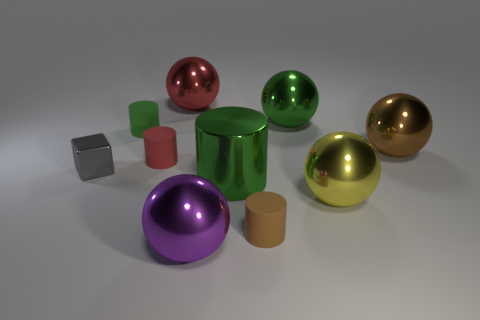What is the shape of the brown thing that is the same material as the purple ball?
Provide a succinct answer. Sphere. Is the number of yellow metallic balls to the right of the metal cube greater than the number of cyan metallic blocks?
Offer a terse response. Yes. What number of things are the same color as the big shiny cylinder?
Offer a very short reply. 2. What number of other things are the same color as the metallic cylinder?
Your response must be concise. 2. Is the number of brown rubber spheres greater than the number of large purple things?
Offer a very short reply. No. What material is the big brown object?
Make the answer very short. Metal. There is a green metallic object on the right side of the brown rubber object; does it have the same size as the purple sphere?
Your answer should be compact. Yes. What size is the green metal thing that is behind the tiny red rubber thing?
Your answer should be compact. Large. How many large red matte blocks are there?
Offer a terse response. 0. There is a metallic thing that is to the left of the purple sphere and behind the tiny metal thing; what color is it?
Give a very brief answer. Red. 